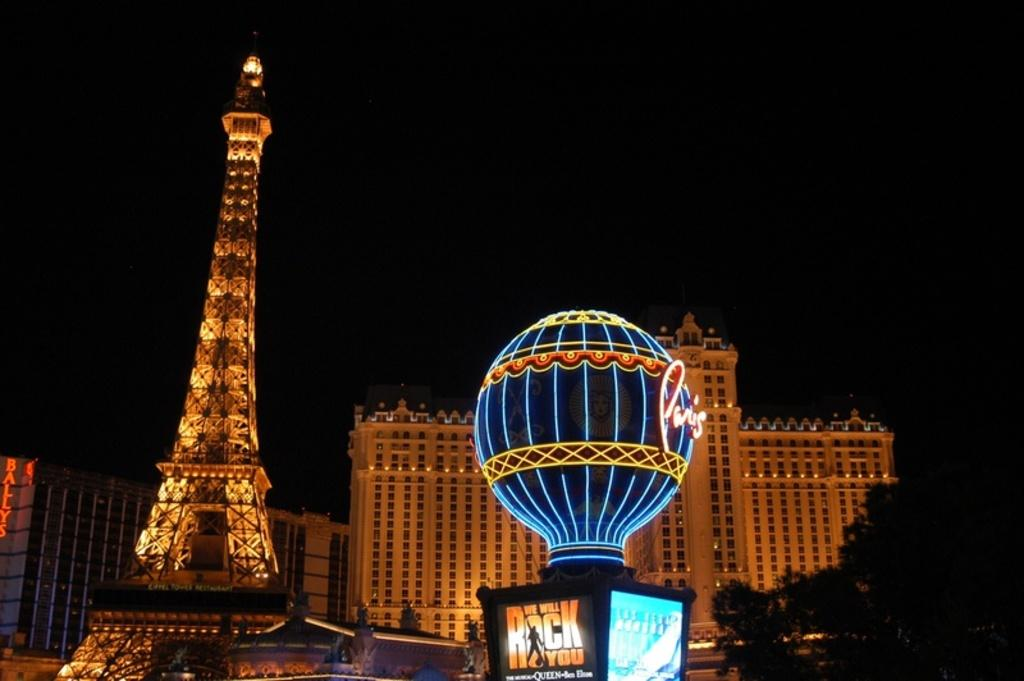What is located in the foreground of the image? There is lighting and a tower in the foreground of the image. What can be seen in the background of the image? There are buildings and trees in the background of the image. What type of kite is being used to cook the stew in the image? There is no kite or stew present in the image. How many lights are visible in the image? The image does not specify the number of lights visible; it only mentions that there is lighting in the foreground. 